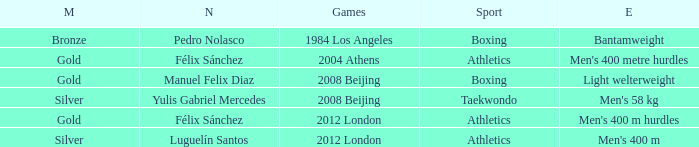Which Medal had a Games of 2008 beijing, and a Sport of taekwondo? Silver. 